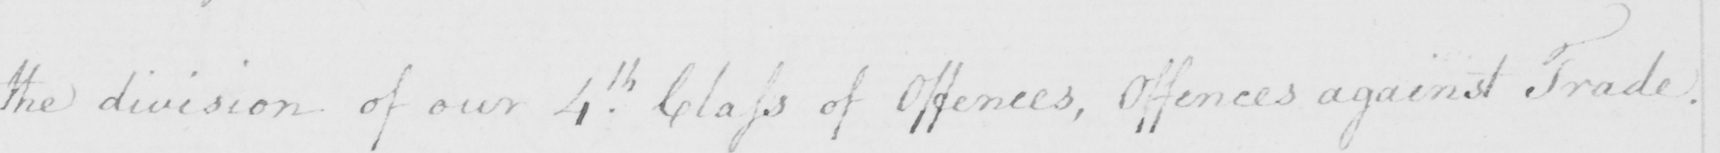Can you read and transcribe this handwriting? the division of our 4th Class of Offences , Offences against Trade . 